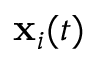Convert formula to latex. <formula><loc_0><loc_0><loc_500><loc_500>x _ { i } ( t )</formula> 